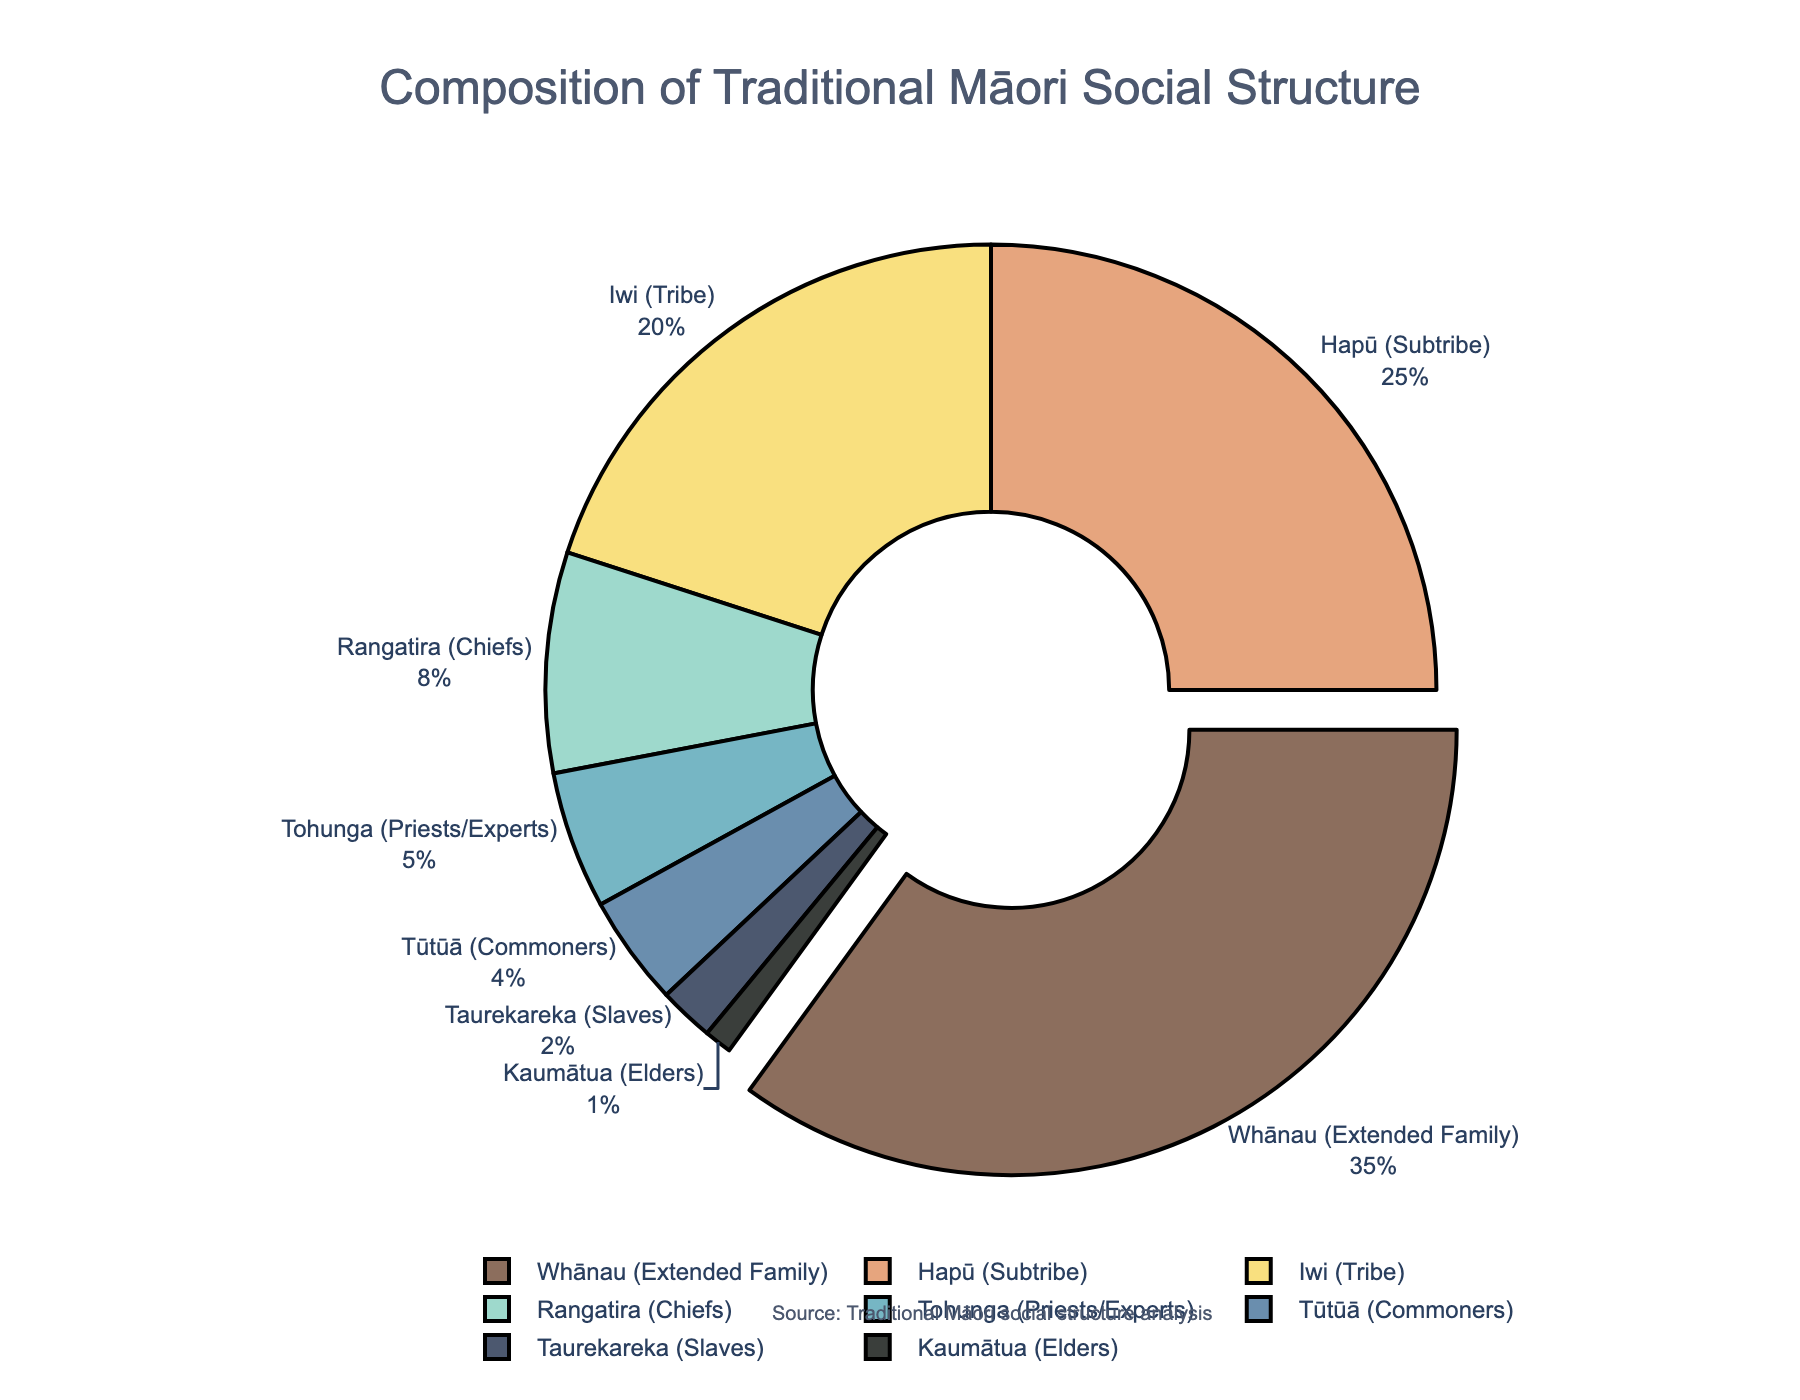What is the most prominent group in the traditional Māori social structure and what percentage do they compose? First, identify the group with the largest segment in the pie chart, which here is the Whānau (Extended Family). The percentage is displayed next to its label.
Answer: Whānau (Extended Family) with 35% What is the combined percentage of the Rangatira (Chiefs) and Tohunga (Priests/Experts)? Look at the percentages for Rangatira (8%) and Tohunga (5%) and add them together: 8% + 5% = 13%.
Answer: 13% Which two groups have a combined percentage equal to that of the Iwi (Tribe)? The Iwi (Tribe) accounts for 20%. Identify two groups that together add up to 20%. Whānau (35%) is too large, so consider smaller groups. Adding Rangatira (8%) and Hapū (25%) exceeds 20%. The suitable pair is Hapū (25%) and Kaumātua (1%): 25% + 1% = 26%. Instead, it should be Tohunga (5%) + Rangatira (8%) + Tūtūā (4%) + Taurekareka (2%) = 19%. However, an exact match would not be found. For smaller options, there are no two exact matches
Answer: No exact match Which group has the smallest representation in the traditional Māori social structure? Identify the smallest segment in the pie chart; it's labeled as "Kaumātua (Elders)" with 1%.
Answer: Kaumātua (Elders) with 1% What is the difference in percentage between the Hapū (Subtribe) and the Whānau (Extended Family)? Subtract the percentage of Hapū (25%) from that of Whānau (35%): 35% - 25% = 10%.
Answer: 10% What proportion of the social structure is composed of commoners (Tūtūā) and slaves (Taurekareka) combined? Add the percentages for Tūtūā (4%) and Taurekareka (2%): 4% + 2% = 6%.
Answer: 6% Which group, represented by a dark green segment, has an 8% proportion? Identify which group’s 8% slice is colored dark green in the pie chart. The group is labeled Rangatira (Chiefs).
Answer: Rangatira (Chiefs) Is the combined contribution of the smallest three groups greater than the Tohunga (Priests/Experts) alone? Identify the smallest three groups: Taurekareka (2%), Tūtūā (4%), and Kaumātua (1%). Adding their percentages: 2% + 4% + 1% = 7%. Compare this with Tohunga's 5%.
Answer: Yes 